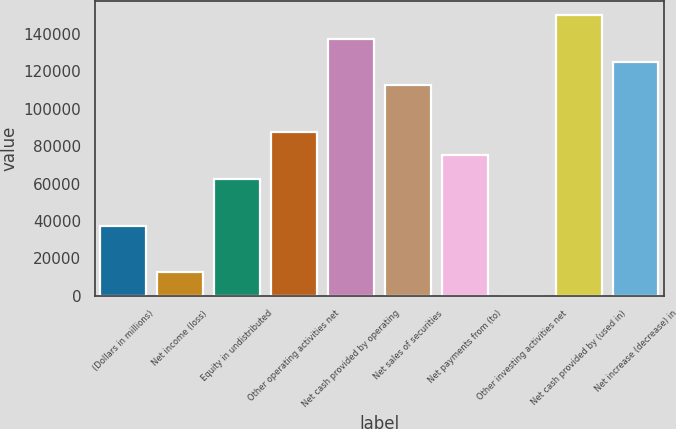Convert chart. <chart><loc_0><loc_0><loc_500><loc_500><bar_chart><fcel>(Dollars in millions)<fcel>Net income (loss)<fcel>Equity in undistributed<fcel>Other operating activities net<fcel>Net cash provided by operating<fcel>Net sales of securities<fcel>Net payments from (to)<fcel>Other investing activities net<fcel>Net cash provided by (used in)<fcel>Net increase (decrease) in<nl><fcel>37502.9<fcel>12506.3<fcel>62499.5<fcel>87496.1<fcel>137489<fcel>112493<fcel>74997.8<fcel>8<fcel>149988<fcel>124991<nl></chart> 